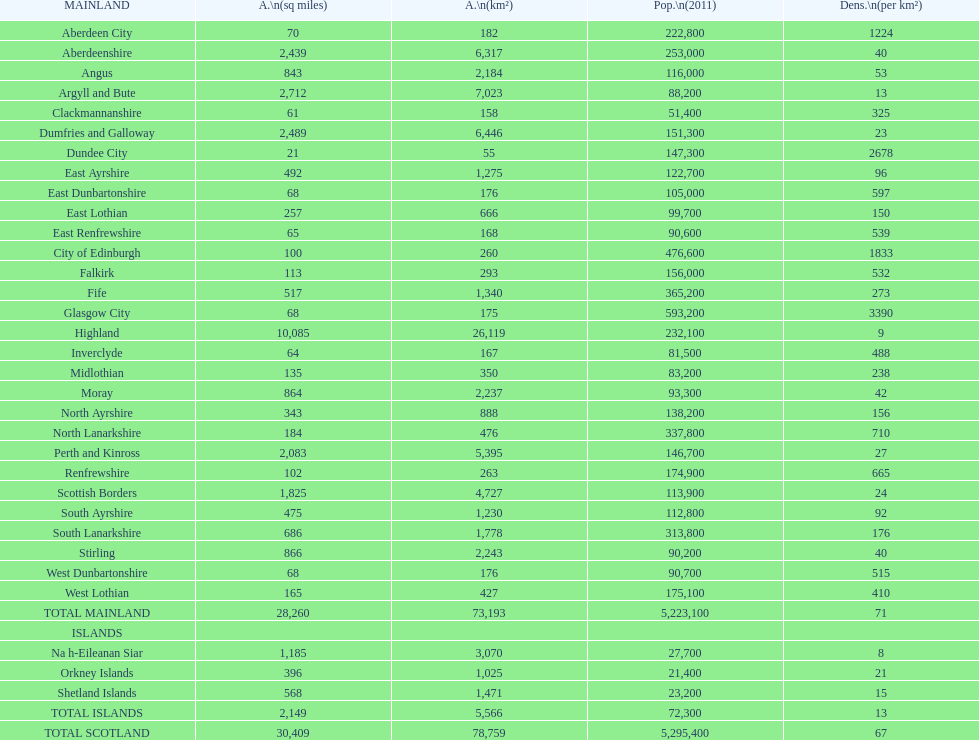What is the total area of east lothian, angus, and dundee city? 1121. 